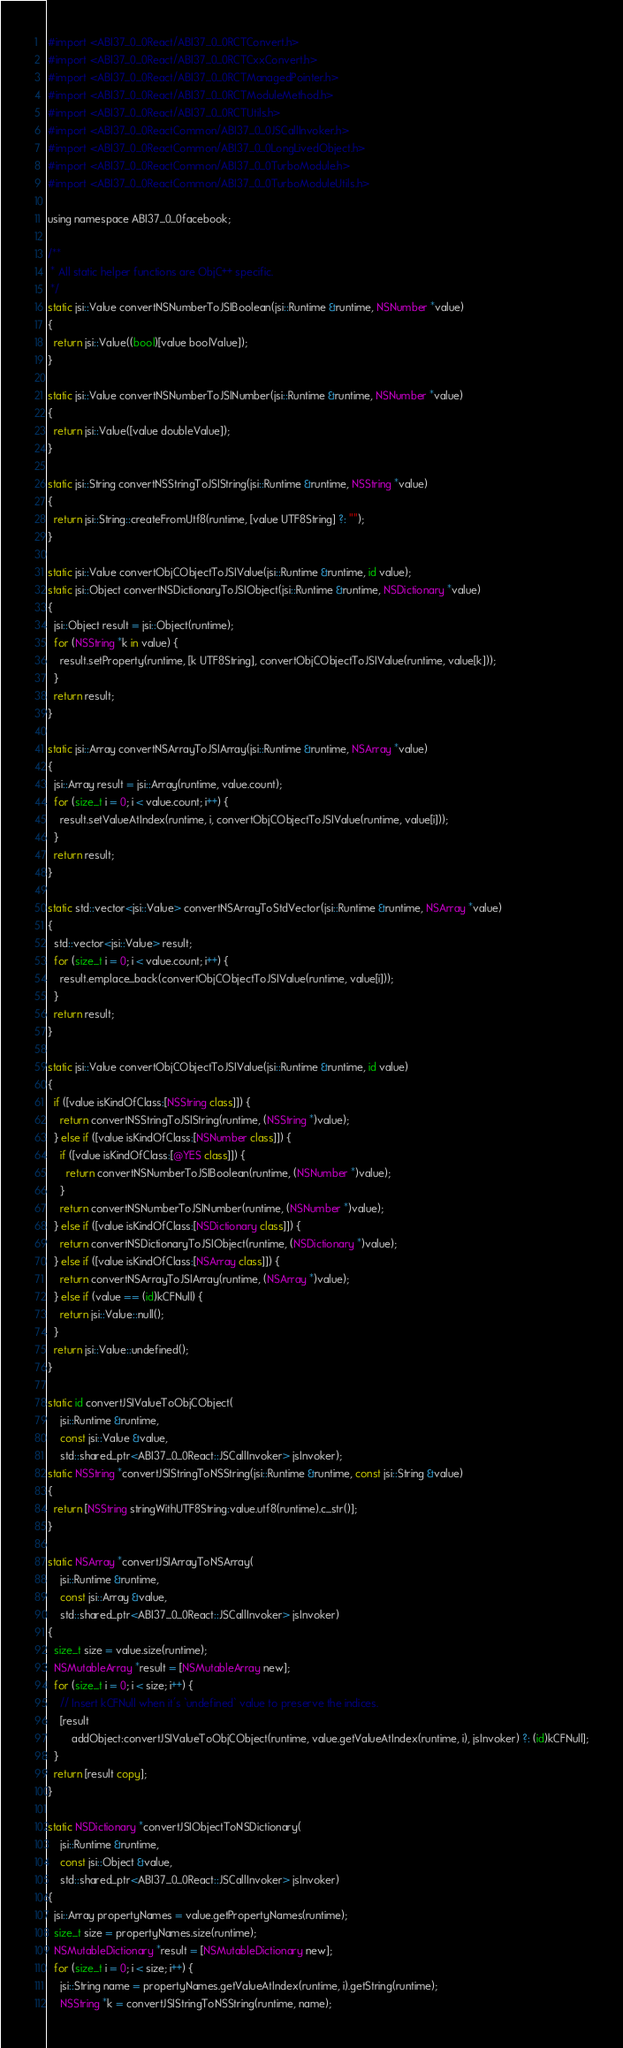Convert code to text. <code><loc_0><loc_0><loc_500><loc_500><_ObjectiveC_>#import <ABI37_0_0React/ABI37_0_0RCTConvert.h>
#import <ABI37_0_0React/ABI37_0_0RCTCxxConvert.h>
#import <ABI37_0_0React/ABI37_0_0RCTManagedPointer.h>
#import <ABI37_0_0React/ABI37_0_0RCTModuleMethod.h>
#import <ABI37_0_0React/ABI37_0_0RCTUtils.h>
#import <ABI37_0_0ReactCommon/ABI37_0_0JSCallInvoker.h>
#import <ABI37_0_0ReactCommon/ABI37_0_0LongLivedObject.h>
#import <ABI37_0_0ReactCommon/ABI37_0_0TurboModule.h>
#import <ABI37_0_0ReactCommon/ABI37_0_0TurboModuleUtils.h>

using namespace ABI37_0_0facebook;

/**
 * All static helper functions are ObjC++ specific.
 */
static jsi::Value convertNSNumberToJSIBoolean(jsi::Runtime &runtime, NSNumber *value)
{
  return jsi::Value((bool)[value boolValue]);
}

static jsi::Value convertNSNumberToJSINumber(jsi::Runtime &runtime, NSNumber *value)
{
  return jsi::Value([value doubleValue]);
}

static jsi::String convertNSStringToJSIString(jsi::Runtime &runtime, NSString *value)
{
  return jsi::String::createFromUtf8(runtime, [value UTF8String] ?: "");
}

static jsi::Value convertObjCObjectToJSIValue(jsi::Runtime &runtime, id value);
static jsi::Object convertNSDictionaryToJSIObject(jsi::Runtime &runtime, NSDictionary *value)
{
  jsi::Object result = jsi::Object(runtime);
  for (NSString *k in value) {
    result.setProperty(runtime, [k UTF8String], convertObjCObjectToJSIValue(runtime, value[k]));
  }
  return result;
}

static jsi::Array convertNSArrayToJSIArray(jsi::Runtime &runtime, NSArray *value)
{
  jsi::Array result = jsi::Array(runtime, value.count);
  for (size_t i = 0; i < value.count; i++) {
    result.setValueAtIndex(runtime, i, convertObjCObjectToJSIValue(runtime, value[i]));
  }
  return result;
}

static std::vector<jsi::Value> convertNSArrayToStdVector(jsi::Runtime &runtime, NSArray *value)
{
  std::vector<jsi::Value> result;
  for (size_t i = 0; i < value.count; i++) {
    result.emplace_back(convertObjCObjectToJSIValue(runtime, value[i]));
  }
  return result;
}

static jsi::Value convertObjCObjectToJSIValue(jsi::Runtime &runtime, id value)
{
  if ([value isKindOfClass:[NSString class]]) {
    return convertNSStringToJSIString(runtime, (NSString *)value);
  } else if ([value isKindOfClass:[NSNumber class]]) {
    if ([value isKindOfClass:[@YES class]]) {
      return convertNSNumberToJSIBoolean(runtime, (NSNumber *)value);
    }
    return convertNSNumberToJSINumber(runtime, (NSNumber *)value);
  } else if ([value isKindOfClass:[NSDictionary class]]) {
    return convertNSDictionaryToJSIObject(runtime, (NSDictionary *)value);
  } else if ([value isKindOfClass:[NSArray class]]) {
    return convertNSArrayToJSIArray(runtime, (NSArray *)value);
  } else if (value == (id)kCFNull) {
    return jsi::Value::null();
  }
  return jsi::Value::undefined();
}

static id convertJSIValueToObjCObject(
    jsi::Runtime &runtime,
    const jsi::Value &value,
    std::shared_ptr<ABI37_0_0React::JSCallInvoker> jsInvoker);
static NSString *convertJSIStringToNSString(jsi::Runtime &runtime, const jsi::String &value)
{
  return [NSString stringWithUTF8String:value.utf8(runtime).c_str()];
}

static NSArray *convertJSIArrayToNSArray(
    jsi::Runtime &runtime,
    const jsi::Array &value,
    std::shared_ptr<ABI37_0_0React::JSCallInvoker> jsInvoker)
{
  size_t size = value.size(runtime);
  NSMutableArray *result = [NSMutableArray new];
  for (size_t i = 0; i < size; i++) {
    // Insert kCFNull when it's `undefined` value to preserve the indices.
    [result
        addObject:convertJSIValueToObjCObject(runtime, value.getValueAtIndex(runtime, i), jsInvoker) ?: (id)kCFNull];
  }
  return [result copy];
}

static NSDictionary *convertJSIObjectToNSDictionary(
    jsi::Runtime &runtime,
    const jsi::Object &value,
    std::shared_ptr<ABI37_0_0React::JSCallInvoker> jsInvoker)
{
  jsi::Array propertyNames = value.getPropertyNames(runtime);
  size_t size = propertyNames.size(runtime);
  NSMutableDictionary *result = [NSMutableDictionary new];
  for (size_t i = 0; i < size; i++) {
    jsi::String name = propertyNames.getValueAtIndex(runtime, i).getString(runtime);
    NSString *k = convertJSIStringToNSString(runtime, name);</code> 